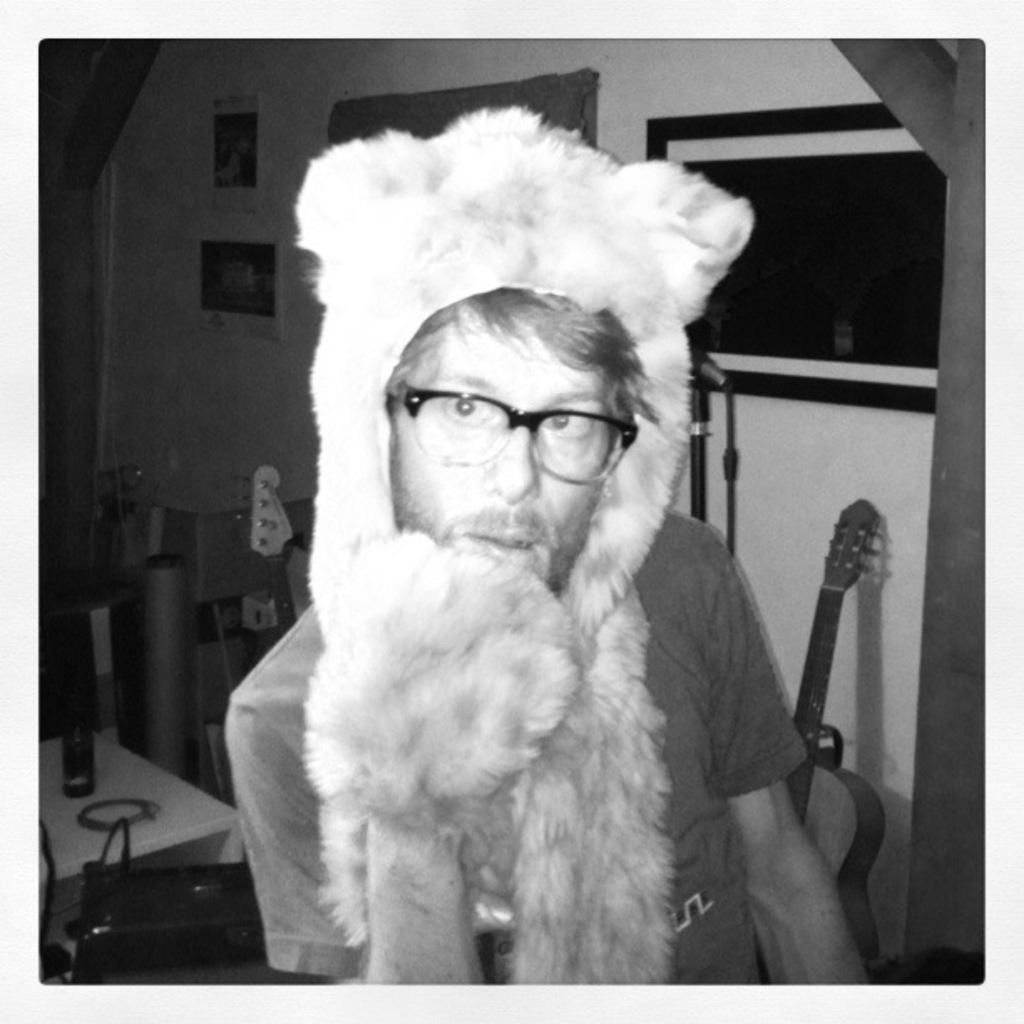How would you summarize this image in a sentence or two? In this picture we can see man wore mask, spectacle and in background we can see bottle, bag on table, wall with frames, guitar. 